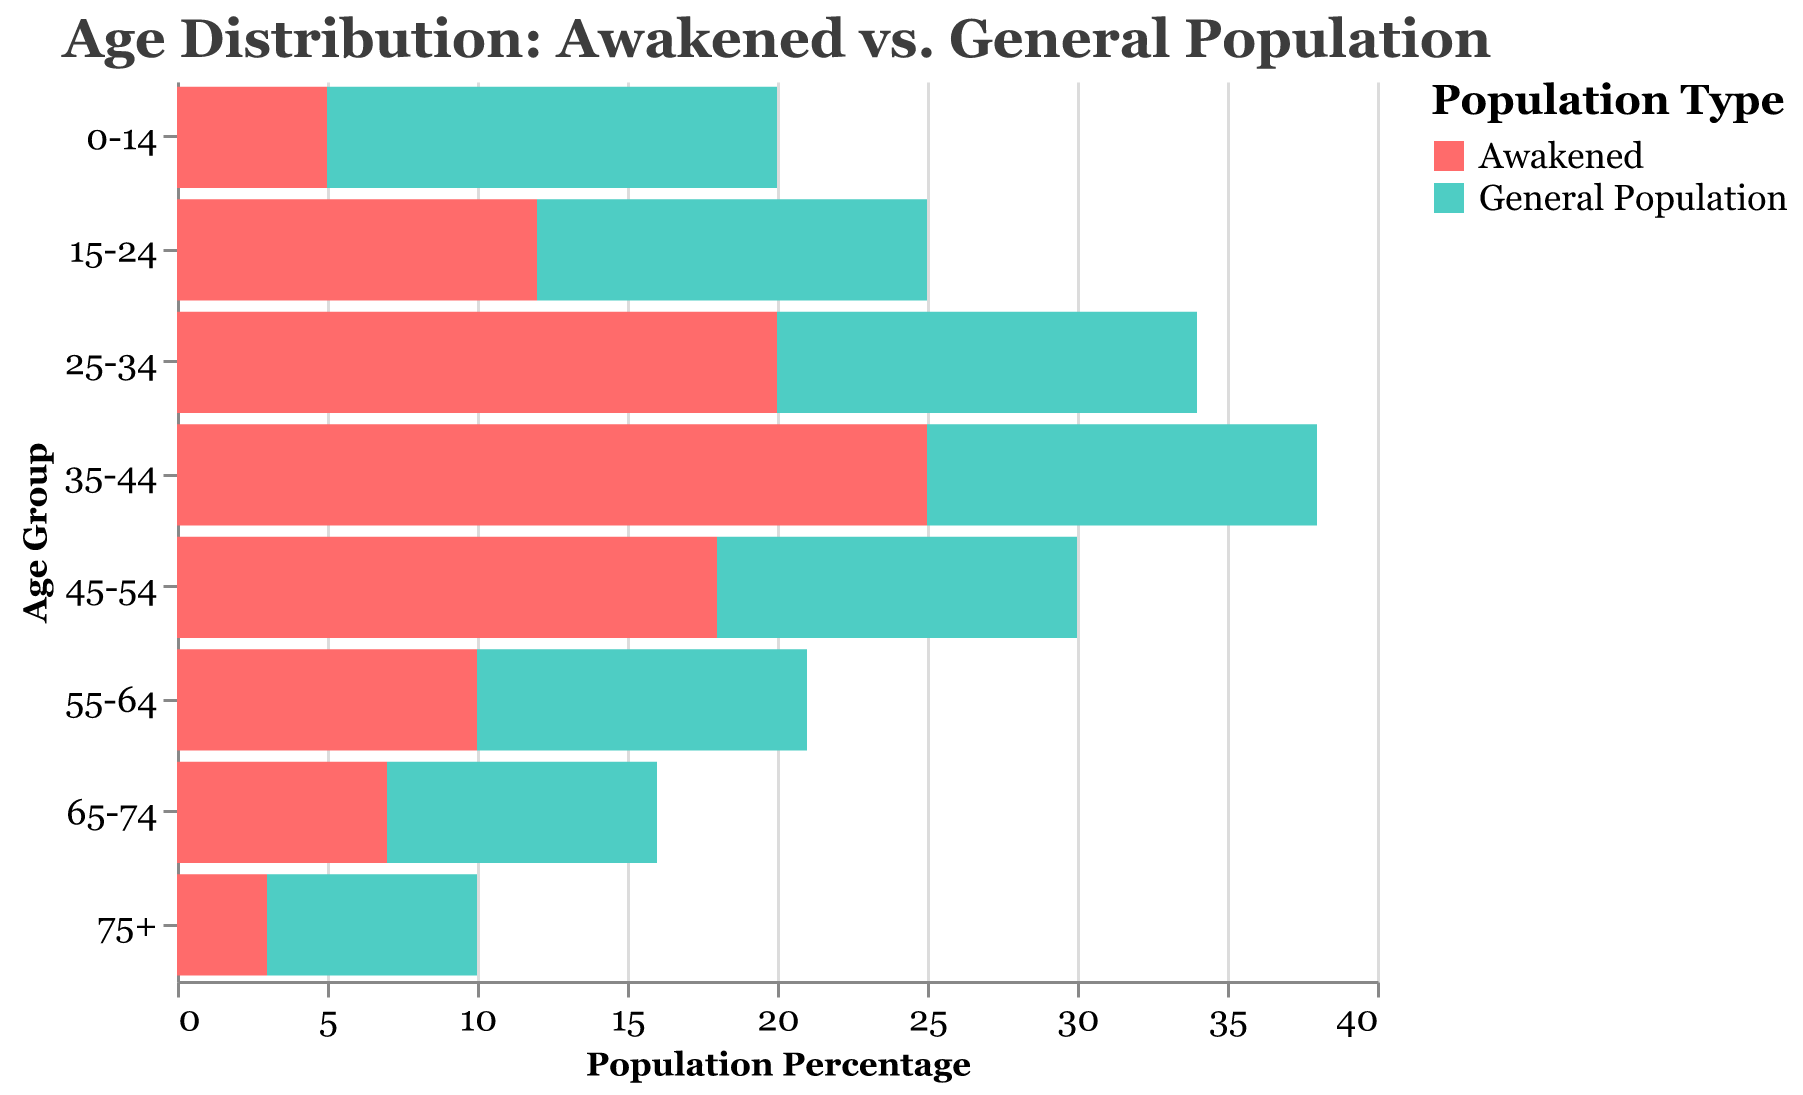What is the title of the chart? The title of the chart is displayed at the top, indicating the main topic of the visualization.
Answer: Age Distribution: Awakened vs. General Population Which age group has the highest percentage of the Awakened population? By looking at the bars corresponding to the Awakened population on the left side, the longest bar indicates the highest percentage.
Answer: 35-44 How does the percentage of the 0-14 age group in the General Population compare to that in the Awakened population? The bar representing the General Population for the 0-14 age group extends from 0 to 15, while the bar for the Awakened population extends from 0 to -5. The General Population has a higher percentage.
Answer: The General Population percentage is higher What is the combined percentage of the Awakened population for the 25-34 and 35-44 age groups? By identifying the values for the 25-34 (-20) and 35-44 (-25) age groups and summing their absolute values, we get 20 + 25.
Answer: 45 Which population has more evenly distributed age groups, and what indicates this? By comparing the lengths of bars for each age group, if they are similar in length for one population, that population distribution is more even. The General Population has more similar bar lengths across age groups.
Answer: General Population How does the percentage of the Awakened population in the 55-64 age group compare to that of the General Population in the same age group? By comparing the lengths of the bars for the 55-64 age group, the Awakened population extends to -10 and the General Population extends to 11. The General Population has a higher percentage.
Answer: General Population has a higher percentage Among the higher age groups (65+), which group shows a closer percentage distribution between the Awakened and General Population? Looking at the bars for the 65-74 and 75+ age groups, the 75+ age group has bars close to -3 for Awakened and 7 for General Population.
Answer: 75+ What is the least represented age group among the Awakened population? By finding the shortest bar on the left side, the least represented group is indicated.
Answer: 75+ What is the percentage difference between the Awakened and General Population in the 15-24 age group? The percentage for the Awakened is -12 and for the General Population is 13. The difference is
Answer: 25 Based on the distribution, what pattern do you observe about the age representation of the Awakened population compared to the General Population? Observing the lengths of the bars for each age group, the percentages are higher (in absolute value) for the middle-aged Awakened population and lower for younger and older ones as compared to the General Population.
Answer: Middle-aged Awakened people are more represented 